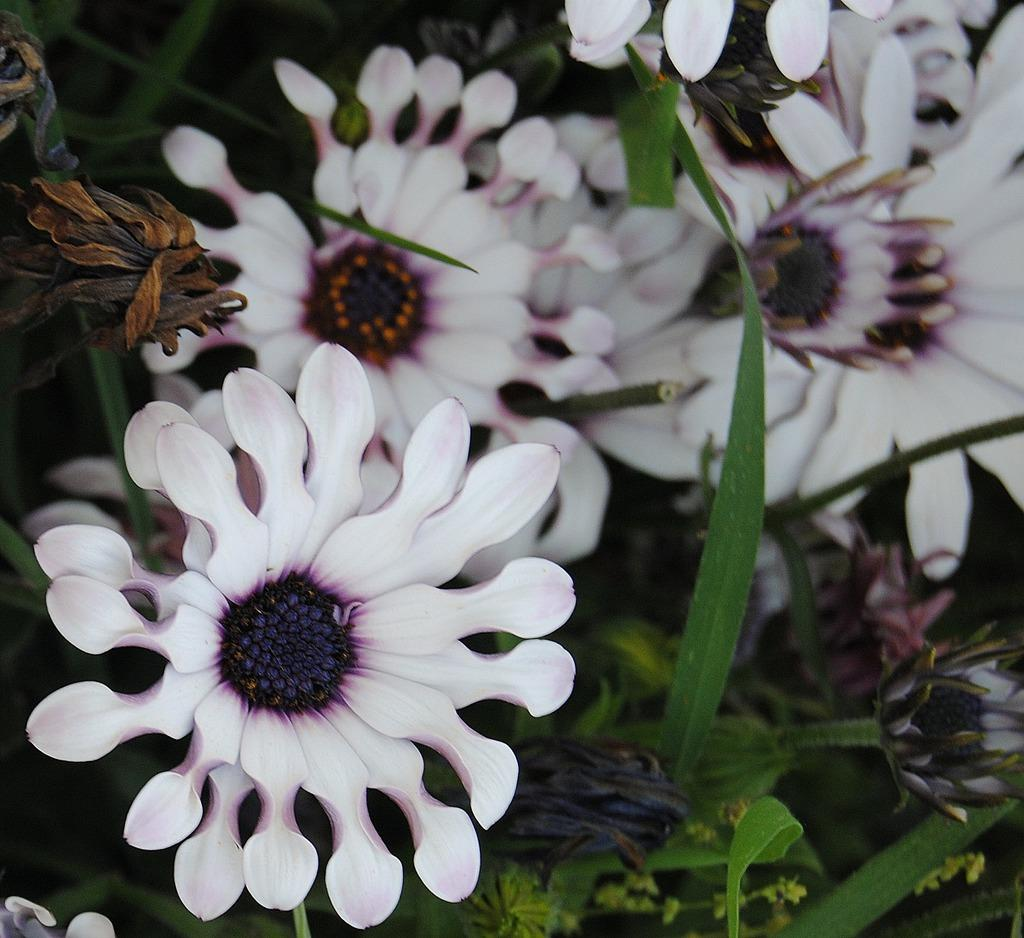What color are the flowers in the image? The flowers in the image are white. What else can be seen among the flowers? Leaves are visible in between the flowers. What language is spoken by the corn in the image? There is no corn present in the image, so it is not possible to determine what language might be spoken by any corn. 